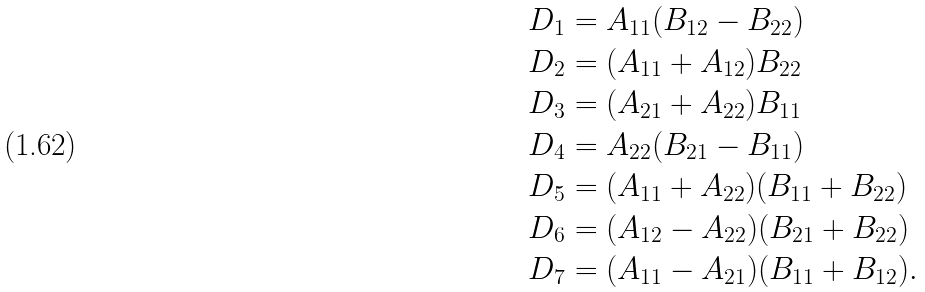Convert formula to latex. <formula><loc_0><loc_0><loc_500><loc_500>& D _ { 1 } = A _ { 1 1 } ( B _ { 1 2 } - B _ { 2 2 } ) \\ & D _ { 2 } = ( A _ { 1 1 } + A _ { 1 2 } ) B _ { 2 2 } \\ & D _ { 3 } = ( A _ { 2 1 } + A _ { 2 2 } ) B _ { 1 1 } \\ & D _ { 4 } = A _ { 2 2 } ( B _ { 2 1 } - B _ { 1 1 } ) \\ & D _ { 5 } = ( A _ { 1 1 } + A _ { 2 2 } ) ( B _ { 1 1 } + B _ { 2 2 } ) \\ & D _ { 6 } = ( A _ { 1 2 } - A _ { 2 2 } ) ( B _ { 2 1 } + B _ { 2 2 } ) \\ & D _ { 7 } = ( A _ { 1 1 } - A _ { 2 1 } ) ( B _ { 1 1 } + B _ { 1 2 } ) . \\</formula> 